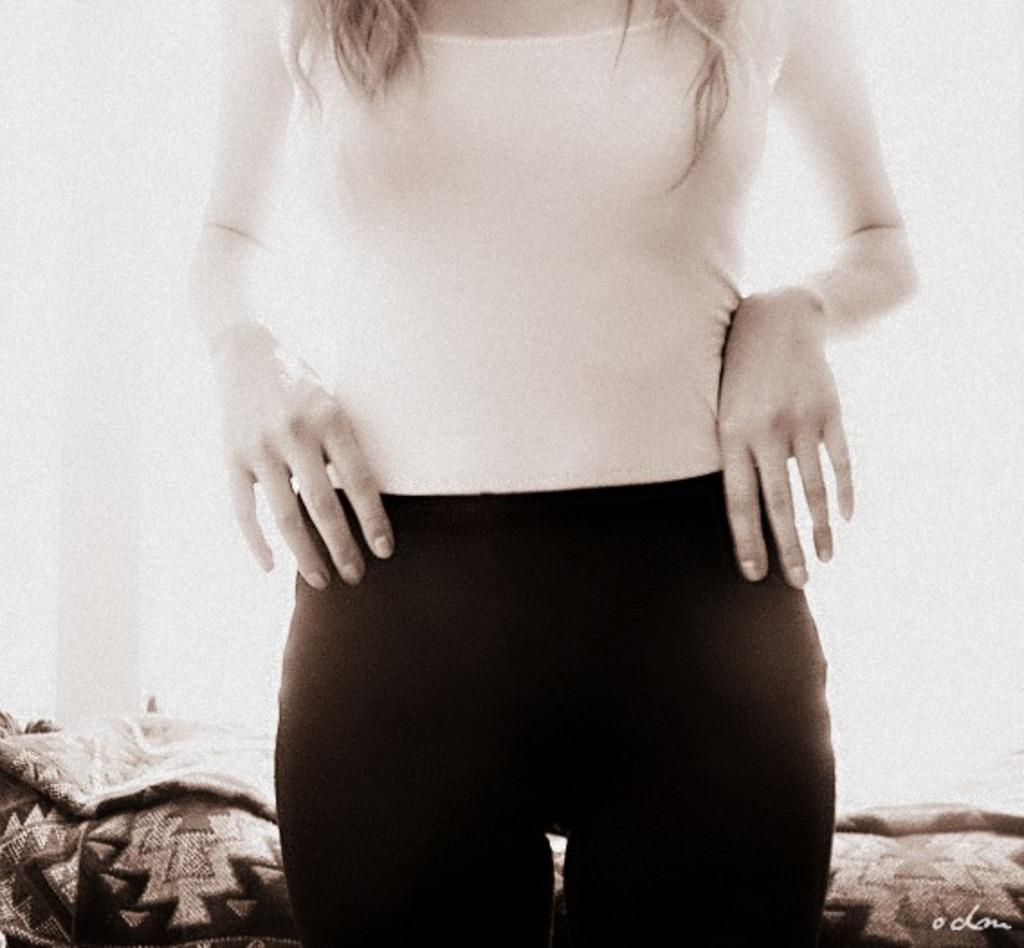What is the main subject in the image? There is a woman standing in the image. What can be seen in the background of the image? There is a blanket and walls in the background of the image. What type of jeans is the woman wearing in the image? The image does not provide information about the woman's jeans, as it only mentions her standing position and the presence of a blanket and walls in the background. 